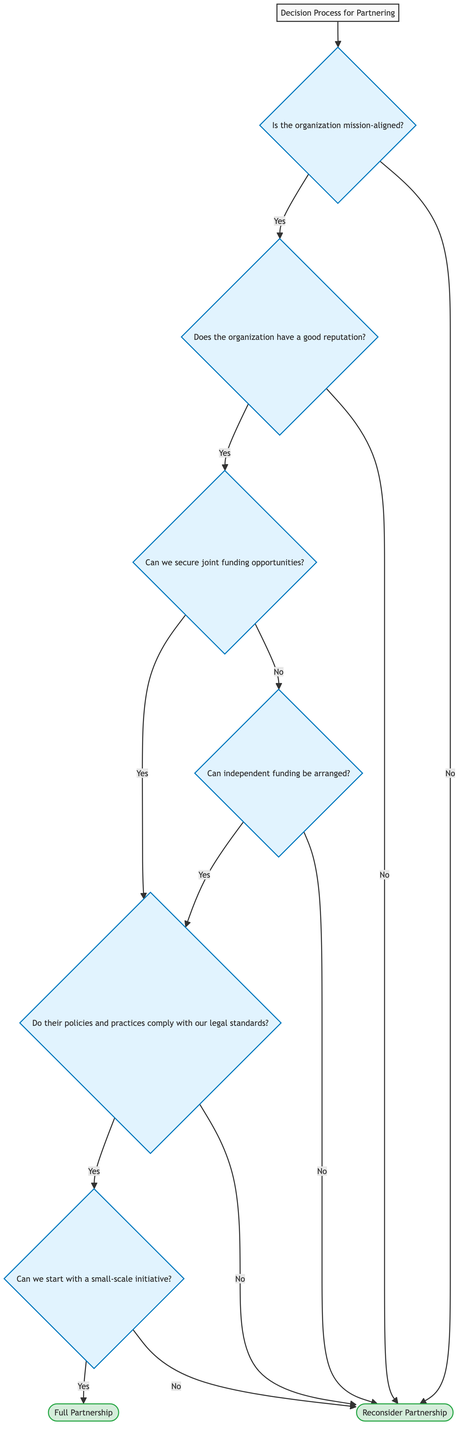What is the first decision point in the diagram? The first decision point in the diagram is to assess whether the organization is mission-aligned. This is represented by the node "Is the organization mission-aligned?"
Answer: Is the organization mission-aligned? What happens if the organization is not mission-aligned? If the organization is not mission-aligned, the outcome in the diagram routes directly to "Reconsider Partnership," which indicates that the partnership should be reevaluated.
Answer: Reconsider Partnership How many nodes are there after the initial assessment if the answer is "Yes"? Starting from the initial assessment and following the path for "Yes," the subsequent nodes are: "Does the organization have a good reputation?", "Can we secure joint funding opportunities?", "Do their policies and practices comply with our legal standards?", "Can we start with a small-scale initiative?", and finally "Full Partnership" or "Reconsider Partnership". This totals 5 nodes.
Answer: 5 What is the next step if the organization's reputation is poor? If the organization's reputation is poor, the diagram leads to "Reconsider Partnership," indicating that the partnership is not advisable due to reputation concerns.
Answer: Reconsider Partnership What must be evaluated before considering a full partnership? Before considering a full partnership, the diagram requires evaluation of whether we can start with a small-scale initiative, indicated by "Can we start with a small-scale initiative?" This assessment is crucial before moving to the potential of a full partnership.
Answer: Can we start with a small-scale initiative? What indicates a successful pathway to a full partnership? A successful pathway to a full partnership is indicated by "Yes" answers at the nodes: confirming mission alignment, obtaining a good reputation, securing joint funding, ensuring legal compliance, and starting with a small-scale initiative. Each of these affirmatives leads to the final node of "Full Partnership."
Answer: Full Partnership What conditional check follows securing funding opportunities? The conditional check that follows "Can we secure joint funding opportunities?" is whether "Do their policies and practices comply with our legal standards?" This is important to ensure legal alignment.
Answer: Do their policies and practices comply with our legal standards? How does independent funding affect the partnership evaluation? If joint funding opportunities are not available, the diagram checks "Can independent funding be arranged?" This evaluation opens alternative pathways to potentially proceed with a partnership, even without joint funding.
Answer: Can independent funding be arranged? 